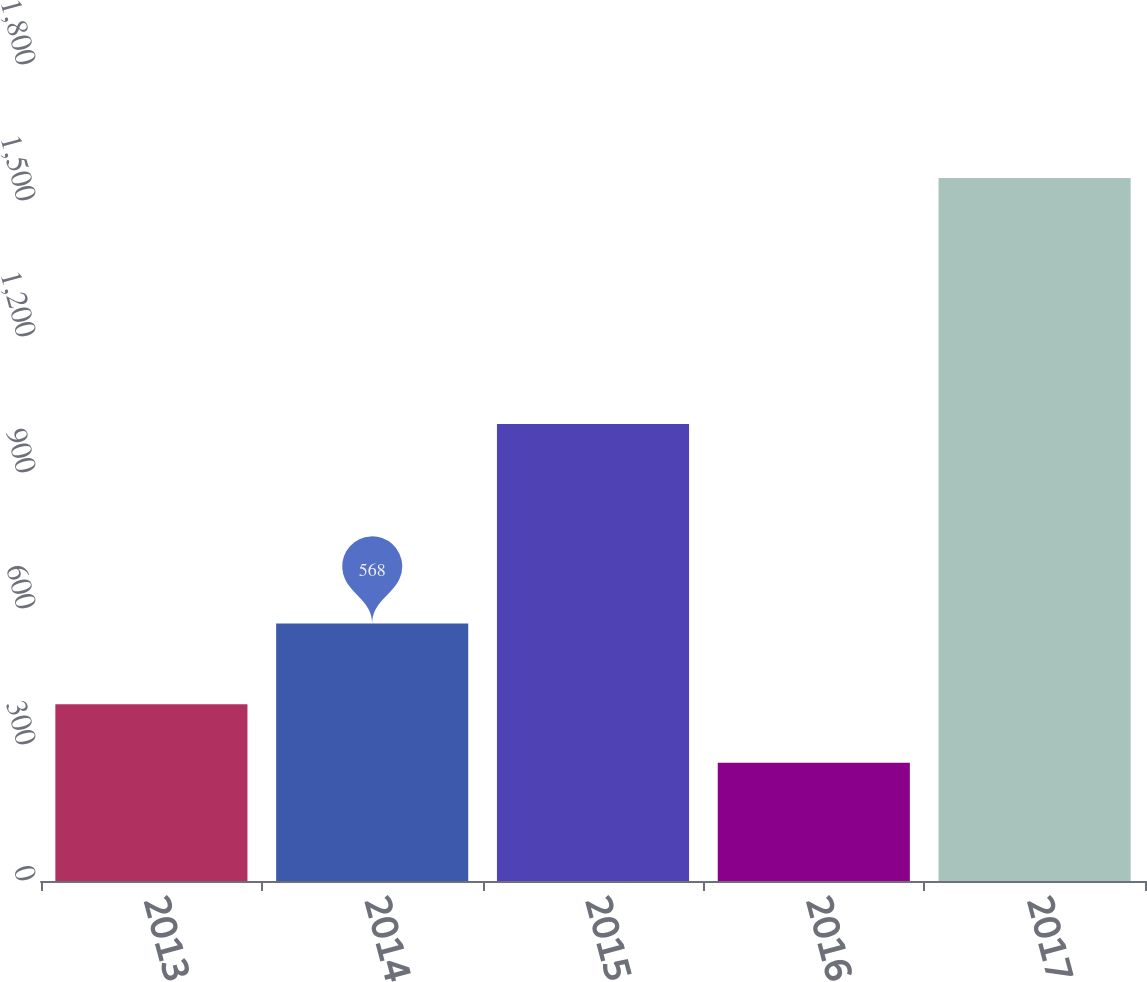<chart> <loc_0><loc_0><loc_500><loc_500><bar_chart><fcel>2013<fcel>2014<fcel>2015<fcel>2016<fcel>2017<nl><fcel>390<fcel>568<fcel>1008<fcel>261<fcel>1551<nl></chart> 